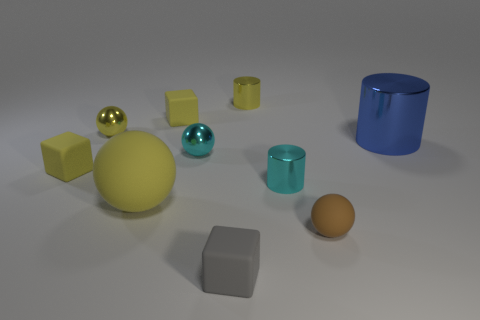What number of other objects are the same shape as the gray object?
Keep it short and to the point. 2. The brown rubber thing is what size?
Provide a short and direct response. Small. How many objects are either small brown things or cyan balls?
Give a very brief answer. 2. How big is the yellow rubber block behind the big blue cylinder?
Your answer should be very brief. Small. What color is the tiny shiny thing that is to the left of the small gray rubber thing and behind the large metallic thing?
Your response must be concise. Yellow. Do the cube behind the big metal object and the small gray thing have the same material?
Your answer should be compact. Yes. There is a large rubber ball; is its color the same as the ball behind the tiny cyan sphere?
Your answer should be compact. Yes. Are there any small rubber spheres in front of the small gray rubber cube?
Give a very brief answer. No. Do the cylinder in front of the big blue cylinder and the yellow object that is right of the gray matte cube have the same size?
Provide a short and direct response. Yes. Are there any other gray matte objects of the same size as the gray thing?
Make the answer very short. No. 